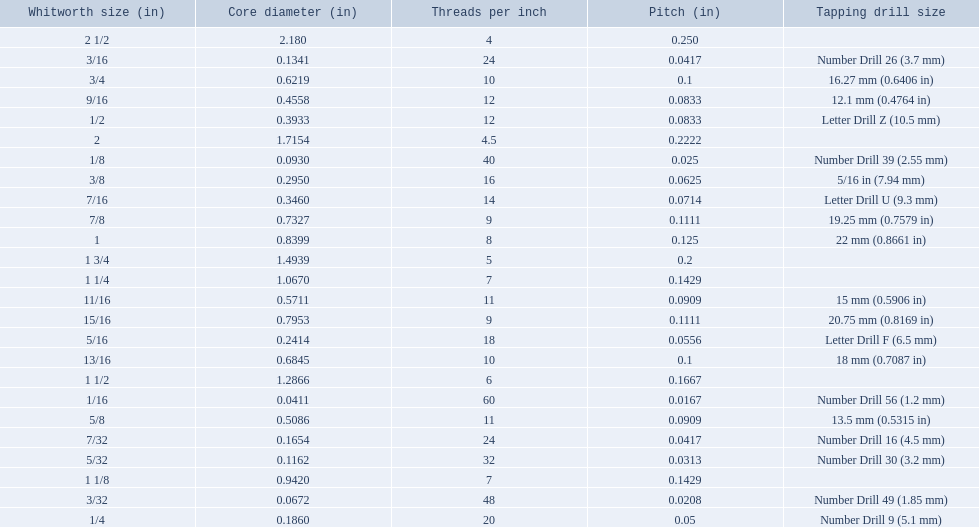What are all the whitworth sizes? 1/16, 3/32, 1/8, 5/32, 3/16, 7/32, 1/4, 5/16, 3/8, 7/16, 1/2, 9/16, 5/8, 11/16, 3/4, 13/16, 7/8, 15/16, 1, 1 1/8, 1 1/4, 1 1/2, 1 3/4, 2, 2 1/2. What are the threads per inch of these sizes? 60, 48, 40, 32, 24, 24, 20, 18, 16, 14, 12, 12, 11, 11, 10, 10, 9, 9, 8, 7, 7, 6, 5, 4.5, 4. Of these, which are 5? 5. What whitworth size has this threads per inch? 1 3/4. 